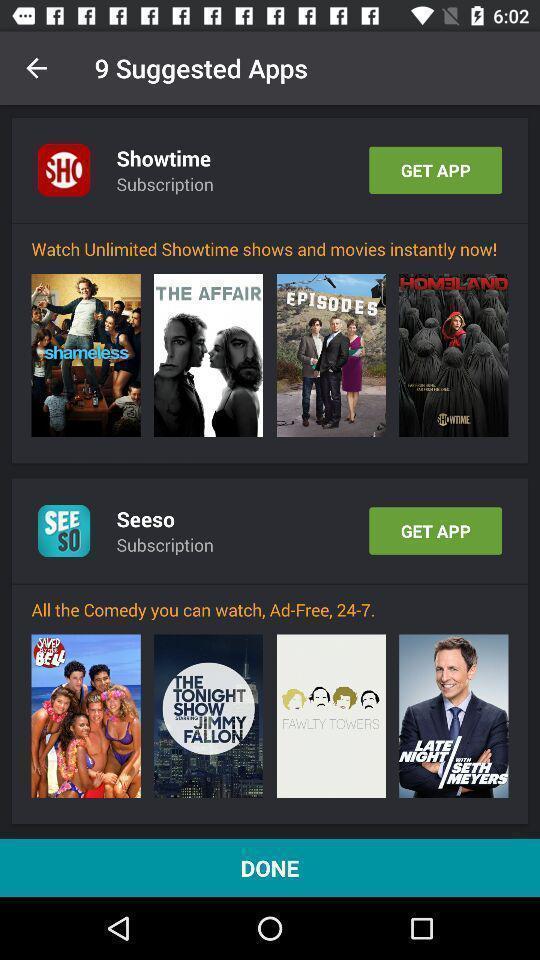Describe the key features of this screenshot. Screen shows about top suggested apps. 